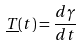Convert formula to latex. <formula><loc_0><loc_0><loc_500><loc_500>\underline { T } ( t ) = \frac { d \gamma } { d t }</formula> 